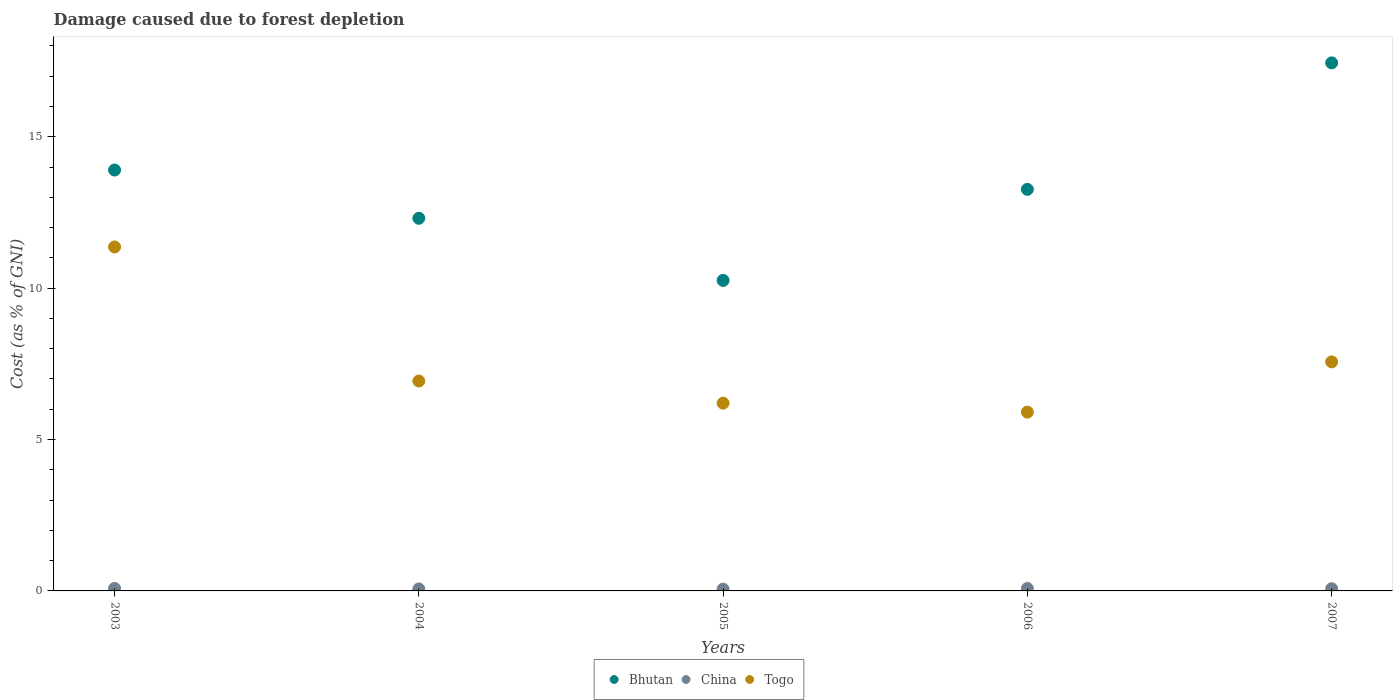How many different coloured dotlines are there?
Your answer should be very brief. 3. Is the number of dotlines equal to the number of legend labels?
Your response must be concise. Yes. What is the cost of damage caused due to forest depletion in Bhutan in 2006?
Provide a short and direct response. 13.26. Across all years, what is the maximum cost of damage caused due to forest depletion in Togo?
Your answer should be compact. 11.36. Across all years, what is the minimum cost of damage caused due to forest depletion in Togo?
Offer a terse response. 5.91. In which year was the cost of damage caused due to forest depletion in Bhutan minimum?
Your answer should be compact. 2005. What is the total cost of damage caused due to forest depletion in Bhutan in the graph?
Provide a short and direct response. 67.17. What is the difference between the cost of damage caused due to forest depletion in Bhutan in 2003 and that in 2004?
Ensure brevity in your answer.  1.59. What is the difference between the cost of damage caused due to forest depletion in Togo in 2006 and the cost of damage caused due to forest depletion in China in 2005?
Provide a short and direct response. 5.84. What is the average cost of damage caused due to forest depletion in Bhutan per year?
Provide a short and direct response. 13.43. In the year 2005, what is the difference between the cost of damage caused due to forest depletion in Bhutan and cost of damage caused due to forest depletion in Togo?
Your response must be concise. 4.05. In how many years, is the cost of damage caused due to forest depletion in Bhutan greater than 13 %?
Make the answer very short. 3. What is the ratio of the cost of damage caused due to forest depletion in China in 2003 to that in 2005?
Your response must be concise. 1.36. What is the difference between the highest and the second highest cost of damage caused due to forest depletion in China?
Keep it short and to the point. 0. What is the difference between the highest and the lowest cost of damage caused due to forest depletion in China?
Provide a succinct answer. 0.02. In how many years, is the cost of damage caused due to forest depletion in China greater than the average cost of damage caused due to forest depletion in China taken over all years?
Your response must be concise. 3. Does the cost of damage caused due to forest depletion in Togo monotonically increase over the years?
Your answer should be compact. No. Is the cost of damage caused due to forest depletion in Bhutan strictly greater than the cost of damage caused due to forest depletion in China over the years?
Offer a terse response. Yes. Is the cost of damage caused due to forest depletion in China strictly less than the cost of damage caused due to forest depletion in Togo over the years?
Keep it short and to the point. Yes. How many years are there in the graph?
Give a very brief answer. 5. Does the graph contain grids?
Provide a succinct answer. No. Where does the legend appear in the graph?
Make the answer very short. Bottom center. What is the title of the graph?
Keep it short and to the point. Damage caused due to forest depletion. What is the label or title of the X-axis?
Keep it short and to the point. Years. What is the label or title of the Y-axis?
Your answer should be very brief. Cost (as % of GNI). What is the Cost (as % of GNI) of Bhutan in 2003?
Provide a short and direct response. 13.9. What is the Cost (as % of GNI) of China in 2003?
Your answer should be compact. 0.08. What is the Cost (as % of GNI) of Togo in 2003?
Give a very brief answer. 11.36. What is the Cost (as % of GNI) of Bhutan in 2004?
Provide a short and direct response. 12.31. What is the Cost (as % of GNI) of China in 2004?
Your response must be concise. 0.07. What is the Cost (as % of GNI) in Togo in 2004?
Provide a short and direct response. 6.93. What is the Cost (as % of GNI) of Bhutan in 2005?
Give a very brief answer. 10.26. What is the Cost (as % of GNI) of China in 2005?
Make the answer very short. 0.06. What is the Cost (as % of GNI) in Togo in 2005?
Offer a very short reply. 6.2. What is the Cost (as % of GNI) in Bhutan in 2006?
Your answer should be compact. 13.26. What is the Cost (as % of GNI) of China in 2006?
Your answer should be compact. 0.08. What is the Cost (as % of GNI) of Togo in 2006?
Ensure brevity in your answer.  5.91. What is the Cost (as % of GNI) of Bhutan in 2007?
Your answer should be very brief. 17.44. What is the Cost (as % of GNI) of China in 2007?
Your response must be concise. 0.07. What is the Cost (as % of GNI) of Togo in 2007?
Provide a succinct answer. 7.57. Across all years, what is the maximum Cost (as % of GNI) in Bhutan?
Offer a very short reply. 17.44. Across all years, what is the maximum Cost (as % of GNI) in China?
Your response must be concise. 0.08. Across all years, what is the maximum Cost (as % of GNI) of Togo?
Your response must be concise. 11.36. Across all years, what is the minimum Cost (as % of GNI) of Bhutan?
Your answer should be very brief. 10.26. Across all years, what is the minimum Cost (as % of GNI) of China?
Your response must be concise. 0.06. Across all years, what is the minimum Cost (as % of GNI) of Togo?
Offer a terse response. 5.91. What is the total Cost (as % of GNI) of Bhutan in the graph?
Your answer should be very brief. 67.17. What is the total Cost (as % of GNI) in China in the graph?
Keep it short and to the point. 0.36. What is the total Cost (as % of GNI) in Togo in the graph?
Provide a short and direct response. 37.97. What is the difference between the Cost (as % of GNI) in Bhutan in 2003 and that in 2004?
Your answer should be very brief. 1.59. What is the difference between the Cost (as % of GNI) of China in 2003 and that in 2004?
Offer a terse response. 0.02. What is the difference between the Cost (as % of GNI) of Togo in 2003 and that in 2004?
Make the answer very short. 4.43. What is the difference between the Cost (as % of GNI) in Bhutan in 2003 and that in 2005?
Provide a short and direct response. 3.65. What is the difference between the Cost (as % of GNI) of China in 2003 and that in 2005?
Ensure brevity in your answer.  0.02. What is the difference between the Cost (as % of GNI) in Togo in 2003 and that in 2005?
Your answer should be compact. 5.16. What is the difference between the Cost (as % of GNI) in Bhutan in 2003 and that in 2006?
Offer a terse response. 0.64. What is the difference between the Cost (as % of GNI) of China in 2003 and that in 2006?
Your response must be concise. 0. What is the difference between the Cost (as % of GNI) in Togo in 2003 and that in 2006?
Provide a short and direct response. 5.46. What is the difference between the Cost (as % of GNI) in Bhutan in 2003 and that in 2007?
Make the answer very short. -3.54. What is the difference between the Cost (as % of GNI) of China in 2003 and that in 2007?
Give a very brief answer. 0.01. What is the difference between the Cost (as % of GNI) of Togo in 2003 and that in 2007?
Make the answer very short. 3.8. What is the difference between the Cost (as % of GNI) in Bhutan in 2004 and that in 2005?
Ensure brevity in your answer.  2.05. What is the difference between the Cost (as % of GNI) of China in 2004 and that in 2005?
Offer a terse response. 0. What is the difference between the Cost (as % of GNI) in Togo in 2004 and that in 2005?
Offer a terse response. 0.73. What is the difference between the Cost (as % of GNI) in Bhutan in 2004 and that in 2006?
Keep it short and to the point. -0.95. What is the difference between the Cost (as % of GNI) in China in 2004 and that in 2006?
Your answer should be compact. -0.02. What is the difference between the Cost (as % of GNI) of Togo in 2004 and that in 2006?
Offer a terse response. 1.03. What is the difference between the Cost (as % of GNI) of Bhutan in 2004 and that in 2007?
Offer a terse response. -5.13. What is the difference between the Cost (as % of GNI) of China in 2004 and that in 2007?
Provide a succinct answer. -0.01. What is the difference between the Cost (as % of GNI) in Togo in 2004 and that in 2007?
Offer a very short reply. -0.63. What is the difference between the Cost (as % of GNI) in Bhutan in 2005 and that in 2006?
Your answer should be very brief. -3.01. What is the difference between the Cost (as % of GNI) of China in 2005 and that in 2006?
Your response must be concise. -0.02. What is the difference between the Cost (as % of GNI) of Togo in 2005 and that in 2006?
Your answer should be very brief. 0.3. What is the difference between the Cost (as % of GNI) of Bhutan in 2005 and that in 2007?
Keep it short and to the point. -7.18. What is the difference between the Cost (as % of GNI) of China in 2005 and that in 2007?
Offer a very short reply. -0.01. What is the difference between the Cost (as % of GNI) in Togo in 2005 and that in 2007?
Keep it short and to the point. -1.36. What is the difference between the Cost (as % of GNI) in Bhutan in 2006 and that in 2007?
Your answer should be compact. -4.18. What is the difference between the Cost (as % of GNI) of China in 2006 and that in 2007?
Provide a succinct answer. 0.01. What is the difference between the Cost (as % of GNI) in Togo in 2006 and that in 2007?
Keep it short and to the point. -1.66. What is the difference between the Cost (as % of GNI) in Bhutan in 2003 and the Cost (as % of GNI) in China in 2004?
Offer a terse response. 13.84. What is the difference between the Cost (as % of GNI) in Bhutan in 2003 and the Cost (as % of GNI) in Togo in 2004?
Your response must be concise. 6.97. What is the difference between the Cost (as % of GNI) in China in 2003 and the Cost (as % of GNI) in Togo in 2004?
Offer a terse response. -6.85. What is the difference between the Cost (as % of GNI) in Bhutan in 2003 and the Cost (as % of GNI) in China in 2005?
Your answer should be compact. 13.84. What is the difference between the Cost (as % of GNI) in Bhutan in 2003 and the Cost (as % of GNI) in Togo in 2005?
Offer a terse response. 7.7. What is the difference between the Cost (as % of GNI) of China in 2003 and the Cost (as % of GNI) of Togo in 2005?
Keep it short and to the point. -6.12. What is the difference between the Cost (as % of GNI) of Bhutan in 2003 and the Cost (as % of GNI) of China in 2006?
Offer a very short reply. 13.82. What is the difference between the Cost (as % of GNI) in Bhutan in 2003 and the Cost (as % of GNI) in Togo in 2006?
Your response must be concise. 8. What is the difference between the Cost (as % of GNI) of China in 2003 and the Cost (as % of GNI) of Togo in 2006?
Offer a very short reply. -5.82. What is the difference between the Cost (as % of GNI) of Bhutan in 2003 and the Cost (as % of GNI) of China in 2007?
Offer a very short reply. 13.83. What is the difference between the Cost (as % of GNI) in Bhutan in 2003 and the Cost (as % of GNI) in Togo in 2007?
Offer a terse response. 6.34. What is the difference between the Cost (as % of GNI) of China in 2003 and the Cost (as % of GNI) of Togo in 2007?
Your response must be concise. -7.48. What is the difference between the Cost (as % of GNI) in Bhutan in 2004 and the Cost (as % of GNI) in China in 2005?
Offer a very short reply. 12.25. What is the difference between the Cost (as % of GNI) in Bhutan in 2004 and the Cost (as % of GNI) in Togo in 2005?
Ensure brevity in your answer.  6.11. What is the difference between the Cost (as % of GNI) in China in 2004 and the Cost (as % of GNI) in Togo in 2005?
Your answer should be compact. -6.14. What is the difference between the Cost (as % of GNI) of Bhutan in 2004 and the Cost (as % of GNI) of China in 2006?
Offer a terse response. 12.23. What is the difference between the Cost (as % of GNI) of Bhutan in 2004 and the Cost (as % of GNI) of Togo in 2006?
Your response must be concise. 6.4. What is the difference between the Cost (as % of GNI) in China in 2004 and the Cost (as % of GNI) in Togo in 2006?
Provide a short and direct response. -5.84. What is the difference between the Cost (as % of GNI) in Bhutan in 2004 and the Cost (as % of GNI) in China in 2007?
Keep it short and to the point. 12.24. What is the difference between the Cost (as % of GNI) of Bhutan in 2004 and the Cost (as % of GNI) of Togo in 2007?
Your response must be concise. 4.74. What is the difference between the Cost (as % of GNI) in Bhutan in 2005 and the Cost (as % of GNI) in China in 2006?
Your answer should be very brief. 10.18. What is the difference between the Cost (as % of GNI) in Bhutan in 2005 and the Cost (as % of GNI) in Togo in 2006?
Give a very brief answer. 4.35. What is the difference between the Cost (as % of GNI) in China in 2005 and the Cost (as % of GNI) in Togo in 2006?
Your response must be concise. -5.84. What is the difference between the Cost (as % of GNI) of Bhutan in 2005 and the Cost (as % of GNI) of China in 2007?
Make the answer very short. 10.18. What is the difference between the Cost (as % of GNI) in Bhutan in 2005 and the Cost (as % of GNI) in Togo in 2007?
Your response must be concise. 2.69. What is the difference between the Cost (as % of GNI) of China in 2005 and the Cost (as % of GNI) of Togo in 2007?
Offer a terse response. -7.5. What is the difference between the Cost (as % of GNI) of Bhutan in 2006 and the Cost (as % of GNI) of China in 2007?
Your response must be concise. 13.19. What is the difference between the Cost (as % of GNI) in Bhutan in 2006 and the Cost (as % of GNI) in Togo in 2007?
Provide a succinct answer. 5.7. What is the difference between the Cost (as % of GNI) of China in 2006 and the Cost (as % of GNI) of Togo in 2007?
Ensure brevity in your answer.  -7.48. What is the average Cost (as % of GNI) in Bhutan per year?
Provide a succinct answer. 13.43. What is the average Cost (as % of GNI) in China per year?
Keep it short and to the point. 0.07. What is the average Cost (as % of GNI) of Togo per year?
Your answer should be very brief. 7.59. In the year 2003, what is the difference between the Cost (as % of GNI) of Bhutan and Cost (as % of GNI) of China?
Provide a short and direct response. 13.82. In the year 2003, what is the difference between the Cost (as % of GNI) in Bhutan and Cost (as % of GNI) in Togo?
Your response must be concise. 2.54. In the year 2003, what is the difference between the Cost (as % of GNI) in China and Cost (as % of GNI) in Togo?
Keep it short and to the point. -11.28. In the year 2004, what is the difference between the Cost (as % of GNI) of Bhutan and Cost (as % of GNI) of China?
Ensure brevity in your answer.  12.24. In the year 2004, what is the difference between the Cost (as % of GNI) in Bhutan and Cost (as % of GNI) in Togo?
Your answer should be very brief. 5.38. In the year 2004, what is the difference between the Cost (as % of GNI) in China and Cost (as % of GNI) in Togo?
Your answer should be compact. -6.87. In the year 2005, what is the difference between the Cost (as % of GNI) of Bhutan and Cost (as % of GNI) of China?
Your response must be concise. 10.2. In the year 2005, what is the difference between the Cost (as % of GNI) of Bhutan and Cost (as % of GNI) of Togo?
Your answer should be very brief. 4.05. In the year 2005, what is the difference between the Cost (as % of GNI) of China and Cost (as % of GNI) of Togo?
Offer a very short reply. -6.14. In the year 2006, what is the difference between the Cost (as % of GNI) in Bhutan and Cost (as % of GNI) in China?
Provide a succinct answer. 13.18. In the year 2006, what is the difference between the Cost (as % of GNI) of Bhutan and Cost (as % of GNI) of Togo?
Your answer should be compact. 7.36. In the year 2006, what is the difference between the Cost (as % of GNI) in China and Cost (as % of GNI) in Togo?
Your response must be concise. -5.83. In the year 2007, what is the difference between the Cost (as % of GNI) in Bhutan and Cost (as % of GNI) in China?
Make the answer very short. 17.37. In the year 2007, what is the difference between the Cost (as % of GNI) of Bhutan and Cost (as % of GNI) of Togo?
Give a very brief answer. 9.88. In the year 2007, what is the difference between the Cost (as % of GNI) in China and Cost (as % of GNI) in Togo?
Your answer should be compact. -7.49. What is the ratio of the Cost (as % of GNI) in Bhutan in 2003 to that in 2004?
Provide a succinct answer. 1.13. What is the ratio of the Cost (as % of GNI) in China in 2003 to that in 2004?
Keep it short and to the point. 1.26. What is the ratio of the Cost (as % of GNI) in Togo in 2003 to that in 2004?
Your response must be concise. 1.64. What is the ratio of the Cost (as % of GNI) in Bhutan in 2003 to that in 2005?
Give a very brief answer. 1.36. What is the ratio of the Cost (as % of GNI) in China in 2003 to that in 2005?
Your answer should be compact. 1.36. What is the ratio of the Cost (as % of GNI) of Togo in 2003 to that in 2005?
Make the answer very short. 1.83. What is the ratio of the Cost (as % of GNI) in Bhutan in 2003 to that in 2006?
Make the answer very short. 1.05. What is the ratio of the Cost (as % of GNI) in Togo in 2003 to that in 2006?
Your answer should be very brief. 1.92. What is the ratio of the Cost (as % of GNI) in Bhutan in 2003 to that in 2007?
Offer a terse response. 0.8. What is the ratio of the Cost (as % of GNI) of China in 2003 to that in 2007?
Offer a terse response. 1.11. What is the ratio of the Cost (as % of GNI) in Togo in 2003 to that in 2007?
Offer a terse response. 1.5. What is the ratio of the Cost (as % of GNI) in Bhutan in 2004 to that in 2005?
Make the answer very short. 1.2. What is the ratio of the Cost (as % of GNI) of China in 2004 to that in 2005?
Your response must be concise. 1.08. What is the ratio of the Cost (as % of GNI) in Togo in 2004 to that in 2005?
Your response must be concise. 1.12. What is the ratio of the Cost (as % of GNI) in Bhutan in 2004 to that in 2006?
Your answer should be very brief. 0.93. What is the ratio of the Cost (as % of GNI) of China in 2004 to that in 2006?
Provide a succinct answer. 0.81. What is the ratio of the Cost (as % of GNI) of Togo in 2004 to that in 2006?
Offer a very short reply. 1.17. What is the ratio of the Cost (as % of GNI) of Bhutan in 2004 to that in 2007?
Keep it short and to the point. 0.71. What is the ratio of the Cost (as % of GNI) in China in 2004 to that in 2007?
Your answer should be very brief. 0.89. What is the ratio of the Cost (as % of GNI) in Togo in 2004 to that in 2007?
Make the answer very short. 0.92. What is the ratio of the Cost (as % of GNI) of Bhutan in 2005 to that in 2006?
Provide a succinct answer. 0.77. What is the ratio of the Cost (as % of GNI) of China in 2005 to that in 2006?
Provide a succinct answer. 0.75. What is the ratio of the Cost (as % of GNI) of Togo in 2005 to that in 2006?
Offer a terse response. 1.05. What is the ratio of the Cost (as % of GNI) of Bhutan in 2005 to that in 2007?
Keep it short and to the point. 0.59. What is the ratio of the Cost (as % of GNI) of China in 2005 to that in 2007?
Keep it short and to the point. 0.82. What is the ratio of the Cost (as % of GNI) in Togo in 2005 to that in 2007?
Your answer should be very brief. 0.82. What is the ratio of the Cost (as % of GNI) in Bhutan in 2006 to that in 2007?
Give a very brief answer. 0.76. What is the ratio of the Cost (as % of GNI) of China in 2006 to that in 2007?
Your response must be concise. 1.09. What is the ratio of the Cost (as % of GNI) in Togo in 2006 to that in 2007?
Offer a terse response. 0.78. What is the difference between the highest and the second highest Cost (as % of GNI) in Bhutan?
Make the answer very short. 3.54. What is the difference between the highest and the second highest Cost (as % of GNI) of China?
Your response must be concise. 0. What is the difference between the highest and the second highest Cost (as % of GNI) of Togo?
Provide a succinct answer. 3.8. What is the difference between the highest and the lowest Cost (as % of GNI) of Bhutan?
Provide a succinct answer. 7.18. What is the difference between the highest and the lowest Cost (as % of GNI) of China?
Your answer should be very brief. 0.02. What is the difference between the highest and the lowest Cost (as % of GNI) in Togo?
Give a very brief answer. 5.46. 